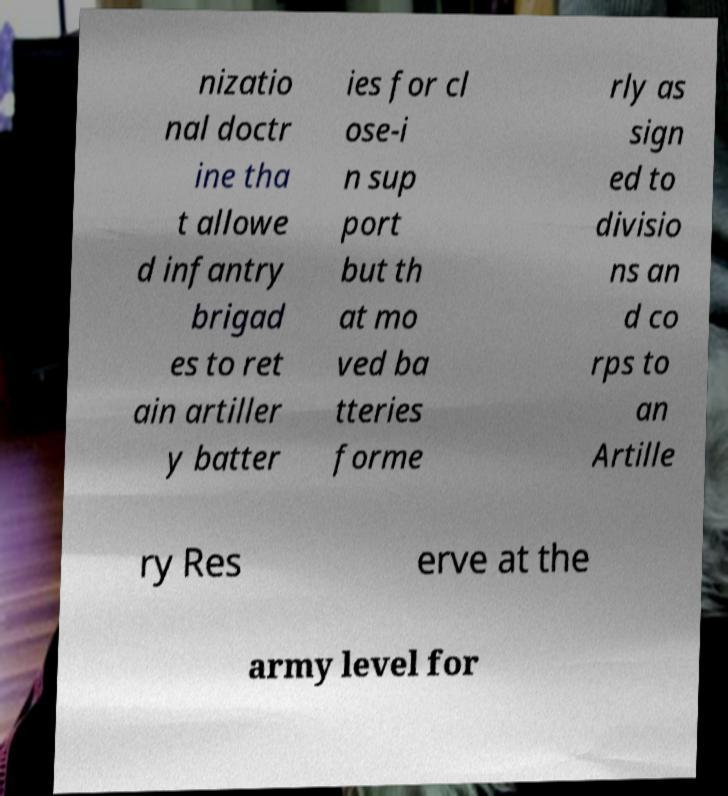Please read and relay the text visible in this image. What does it say? nizatio nal doctr ine tha t allowe d infantry brigad es to ret ain artiller y batter ies for cl ose-i n sup port but th at mo ved ba tteries forme rly as sign ed to divisio ns an d co rps to an Artille ry Res erve at the army level for 